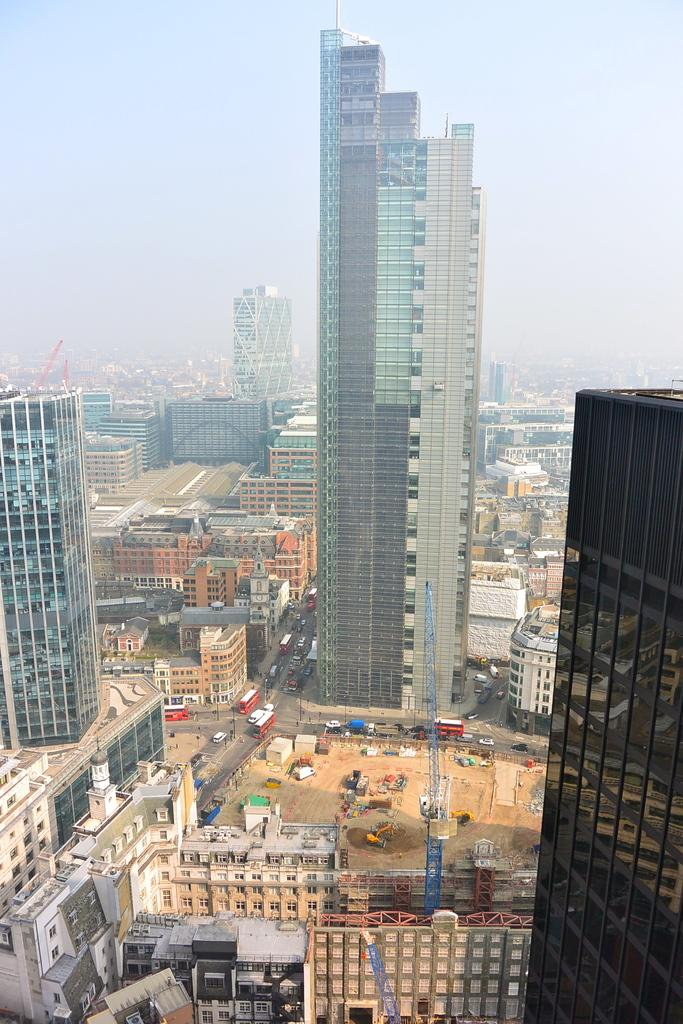What type of structures can be seen in the image? There are buildings, towers, and houses in the image. What type of transportation infrastructure is present in the image? There are roads and vehicles in the image. What can be seen in the background of the image? The sky is visible in the background of the image. Where are the chickens roaming in the image? There are no chickens present in the image. What type of dinner is being served in the image? There is no dinner being served in the image. 